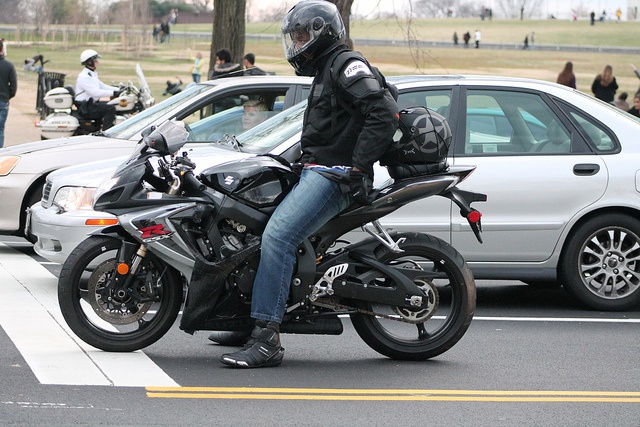Describe the objects in this image and their specific colors. I can see motorcycle in gray, black, darkgray, and lightgray tones, car in gray, lightgray, darkgray, and black tones, people in gray, black, and darkblue tones, car in gray, white, black, and darkgray tones, and motorcycle in gray, lightgray, darkgray, and black tones in this image. 